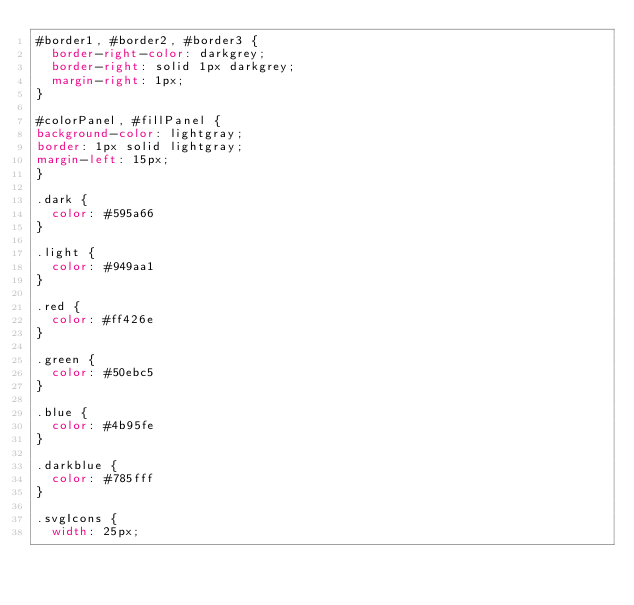<code> <loc_0><loc_0><loc_500><loc_500><_CSS_>#border1, #border2, #border3 {
  border-right-color: darkgrey;
  border-right: solid 1px darkgrey;
  margin-right: 1px;
}

#colorPanel, #fillPanel {
background-color: lightgray;
border: 1px solid lightgray;
margin-left: 15px;
}

.dark {
  color: #595a66
}

.light {
  color: #949aa1
}

.red {
  color: #ff426e
}

.green {
  color: #50ebc5
}

.blue {
  color: #4b95fe
}

.darkblue {
  color: #785fff
}

.svgIcons {
  width: 25px;</code> 